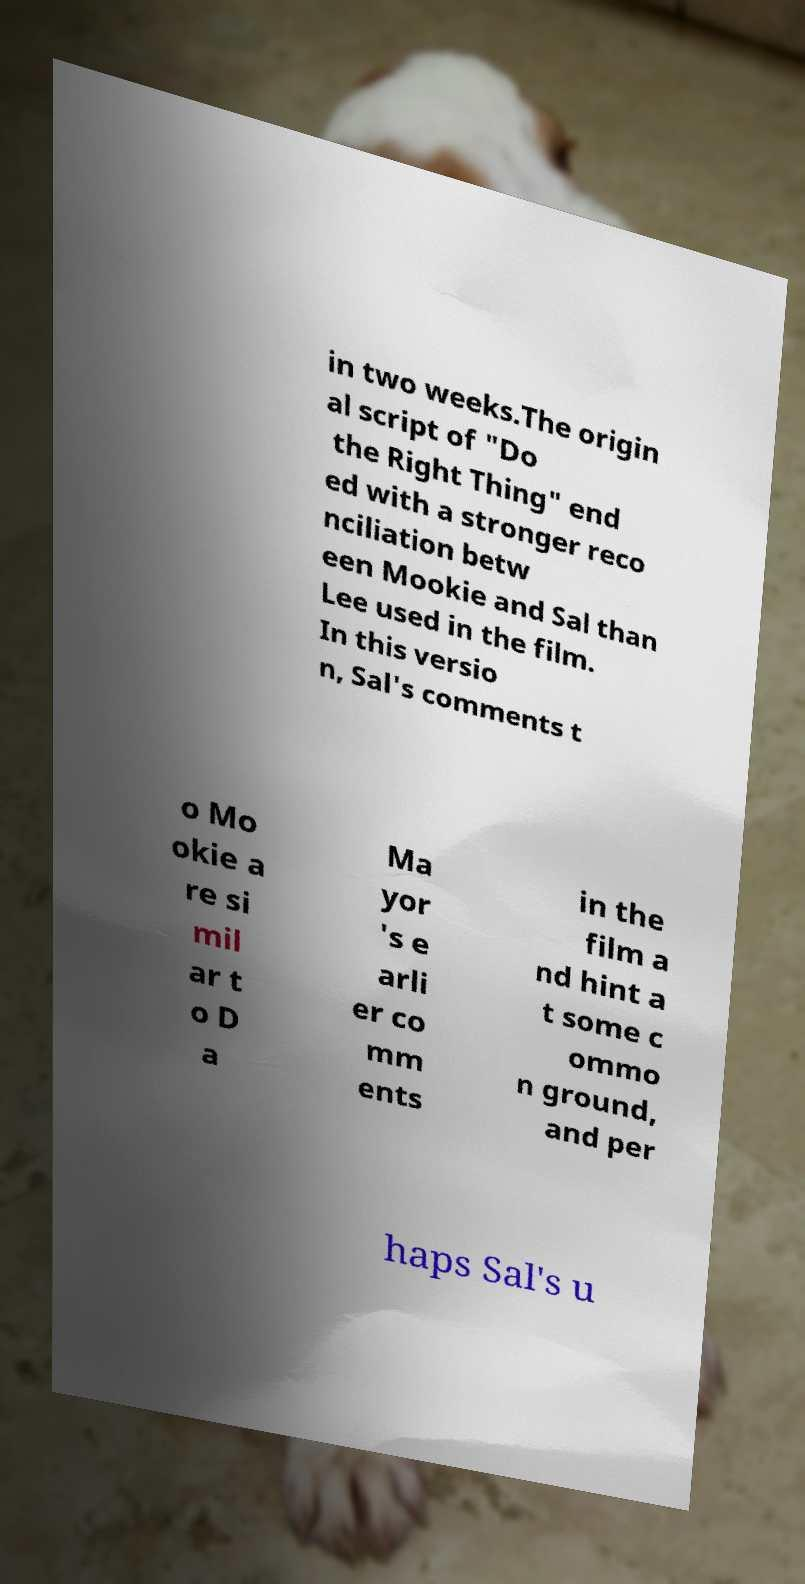Could you assist in decoding the text presented in this image and type it out clearly? in two weeks.The origin al script of "Do the Right Thing" end ed with a stronger reco nciliation betw een Mookie and Sal than Lee used in the film. In this versio n, Sal's comments t o Mo okie a re si mil ar t o D a Ma yor 's e arli er co mm ents in the film a nd hint a t some c ommo n ground, and per haps Sal's u 